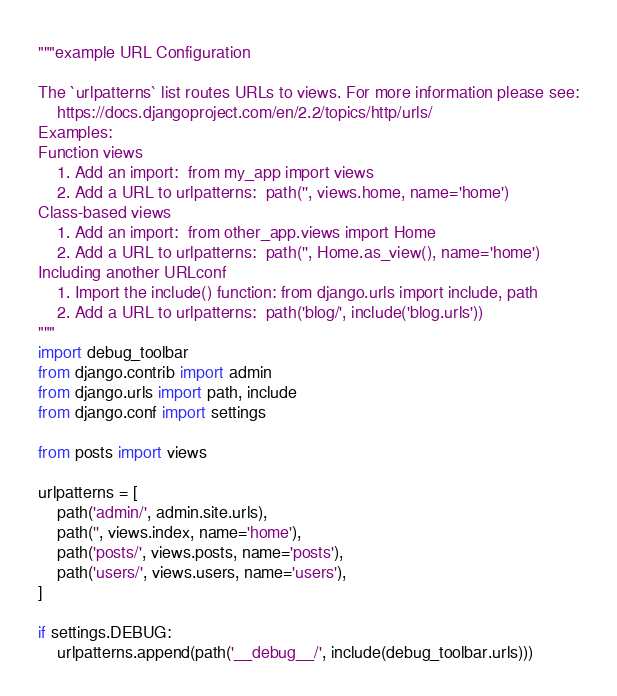<code> <loc_0><loc_0><loc_500><loc_500><_Python_>"""example URL Configuration

The `urlpatterns` list routes URLs to views. For more information please see:
    https://docs.djangoproject.com/en/2.2/topics/http/urls/
Examples:
Function views
    1. Add an import:  from my_app import views
    2. Add a URL to urlpatterns:  path('', views.home, name='home')
Class-based views
    1. Add an import:  from other_app.views import Home
    2. Add a URL to urlpatterns:  path('', Home.as_view(), name='home')
Including another URLconf
    1. Import the include() function: from django.urls import include, path
    2. Add a URL to urlpatterns:  path('blog/', include('blog.urls'))
"""
import debug_toolbar
from django.contrib import admin
from django.urls import path, include
from django.conf import settings

from posts import views

urlpatterns = [
    path('admin/', admin.site.urls),
    path('', views.index, name='home'),
    path('posts/', views.posts, name='posts'),
    path('users/', views.users, name='users'),
]

if settings.DEBUG:
    urlpatterns.append(path('__debug__/', include(debug_toolbar.urls)))
</code> 